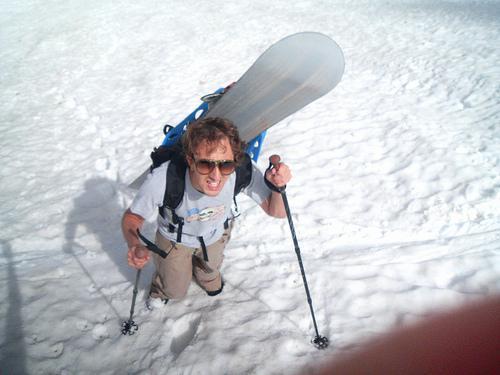How many ski poles are there?
Give a very brief answer. 2. 